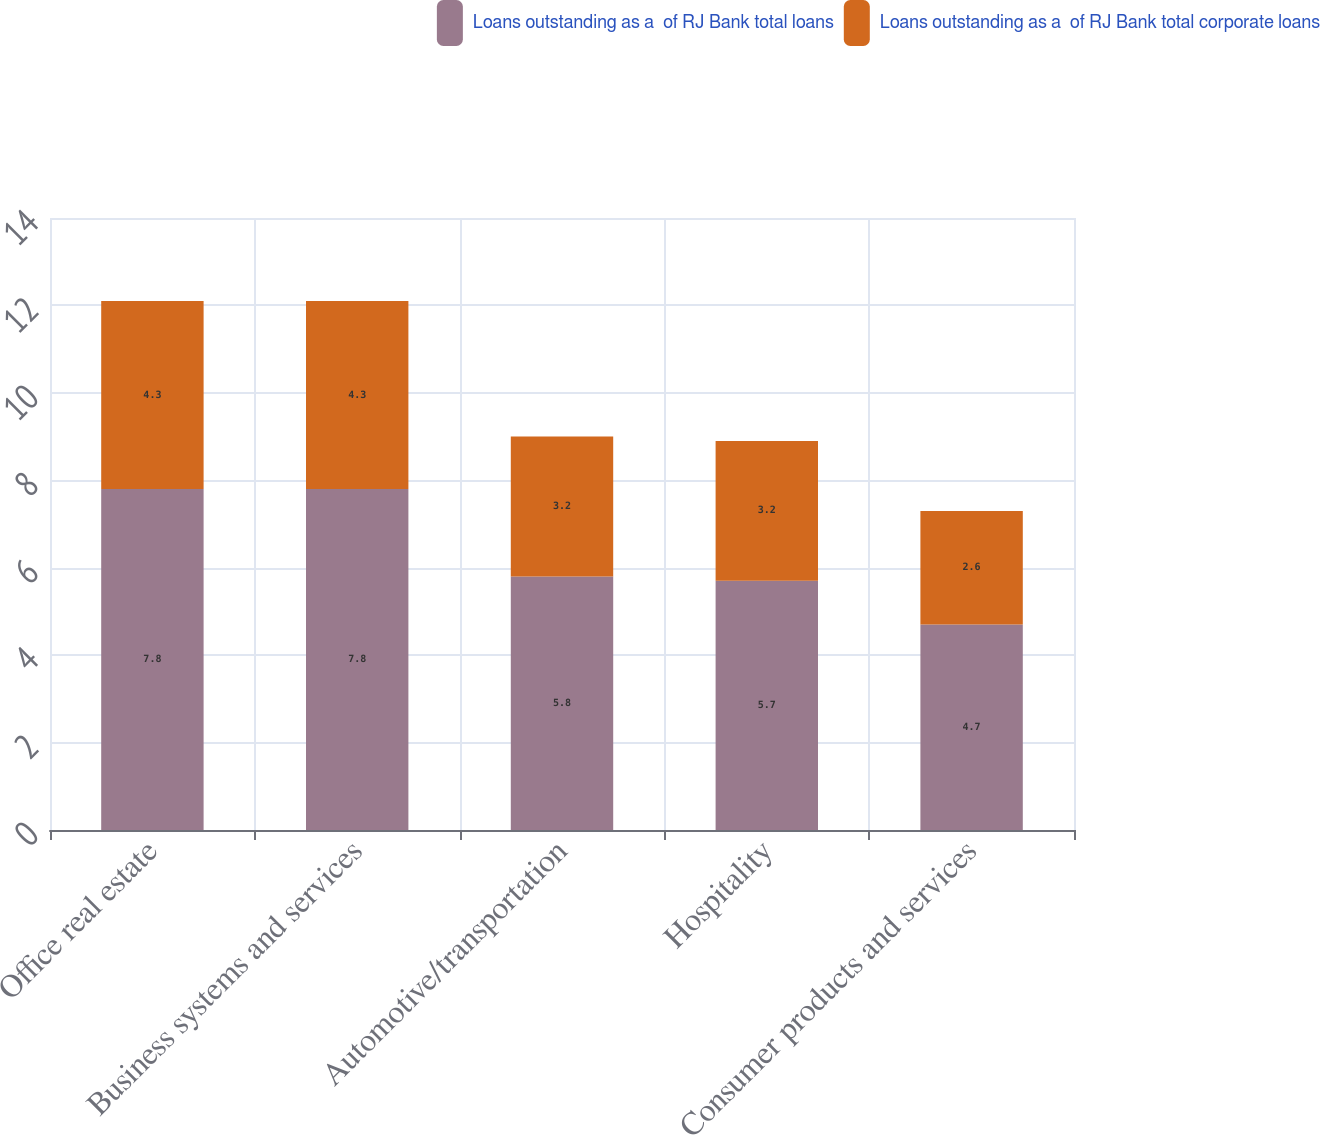Convert chart. <chart><loc_0><loc_0><loc_500><loc_500><stacked_bar_chart><ecel><fcel>Office real estate<fcel>Business systems and services<fcel>Automotive/transportation<fcel>Hospitality<fcel>Consumer products and services<nl><fcel>Loans outstanding as a  of RJ Bank total loans<fcel>7.8<fcel>7.8<fcel>5.8<fcel>5.7<fcel>4.7<nl><fcel>Loans outstanding as a  of RJ Bank total corporate loans<fcel>4.3<fcel>4.3<fcel>3.2<fcel>3.2<fcel>2.6<nl></chart> 